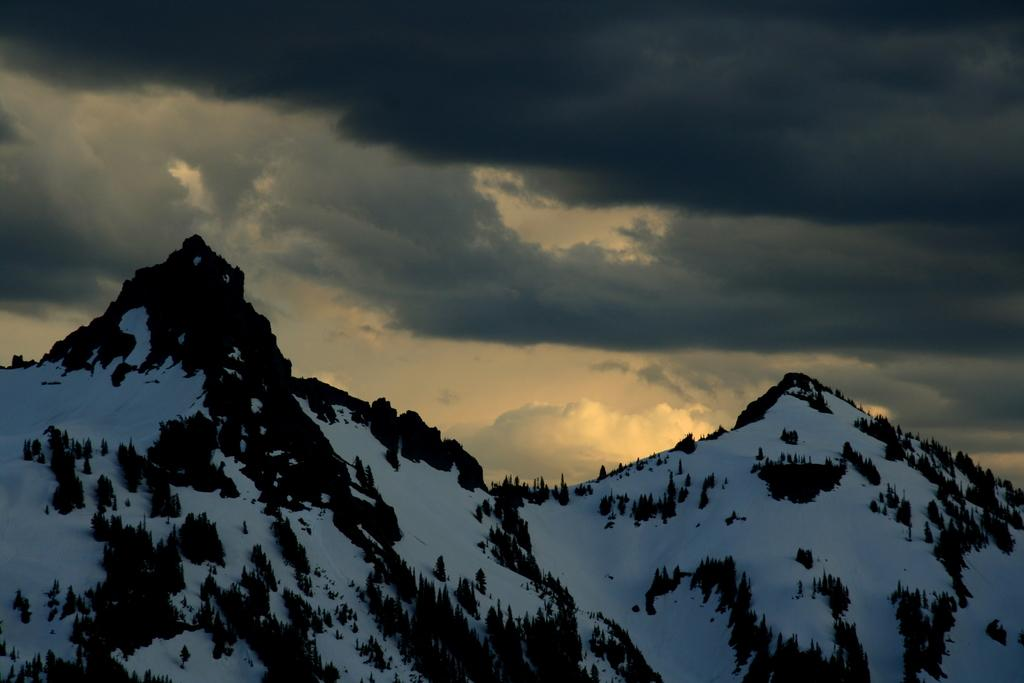What type of landscape is depicted in the image? The image features snowy mountains. Are there any plants visible on the snowy mountains? Yes, there are trees on the snowy mountains. What can be seen in the background of the image? The sky is visible in the background of the image. How would you describe the weather based on the appearance of the sky? The sky appears to be cloudy, which might suggest a cold or overcast day. What type of print can be seen on the vest worn by the church in the image? There is no church, vest, or print present in the image. 